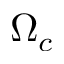<formula> <loc_0><loc_0><loc_500><loc_500>\Omega _ { c }</formula> 